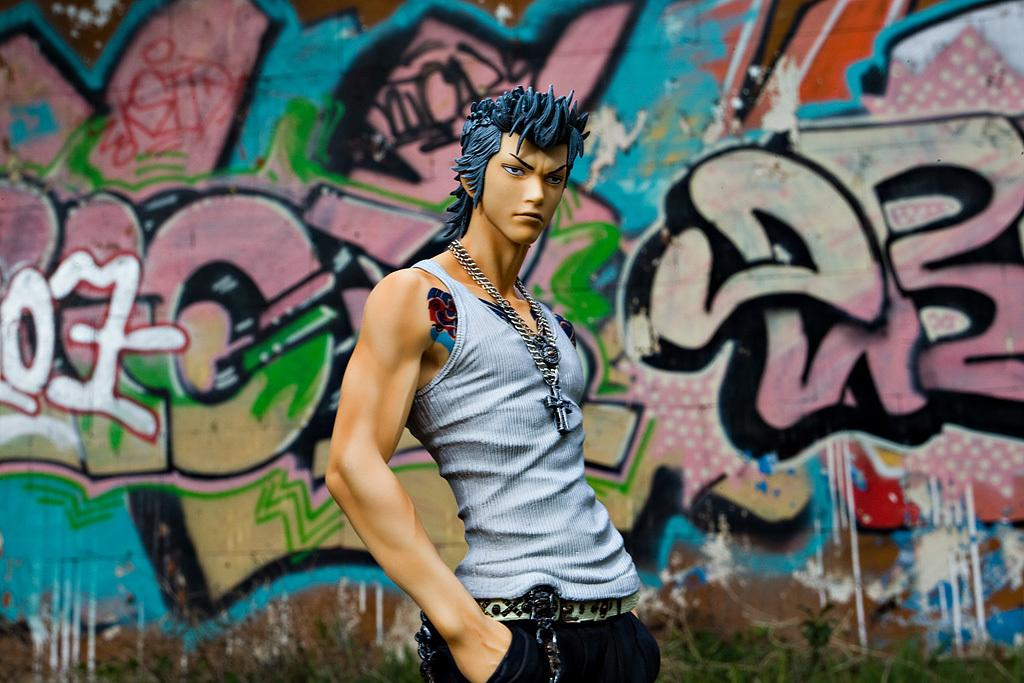What is the main subject in the front of the image? There is a statue in the front of the image. What can be seen in the background of the image? There is a wall in the background of the image. What is on the wall in the image? There is a painting on the wall. How many times does the bird cough in the image? There is no bird present in the image, so it cannot cough. 